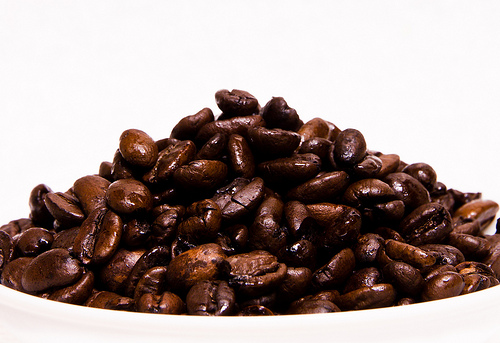<image>
Is there a bean next to the bean? Yes. The bean is positioned adjacent to the bean, located nearby in the same general area. 